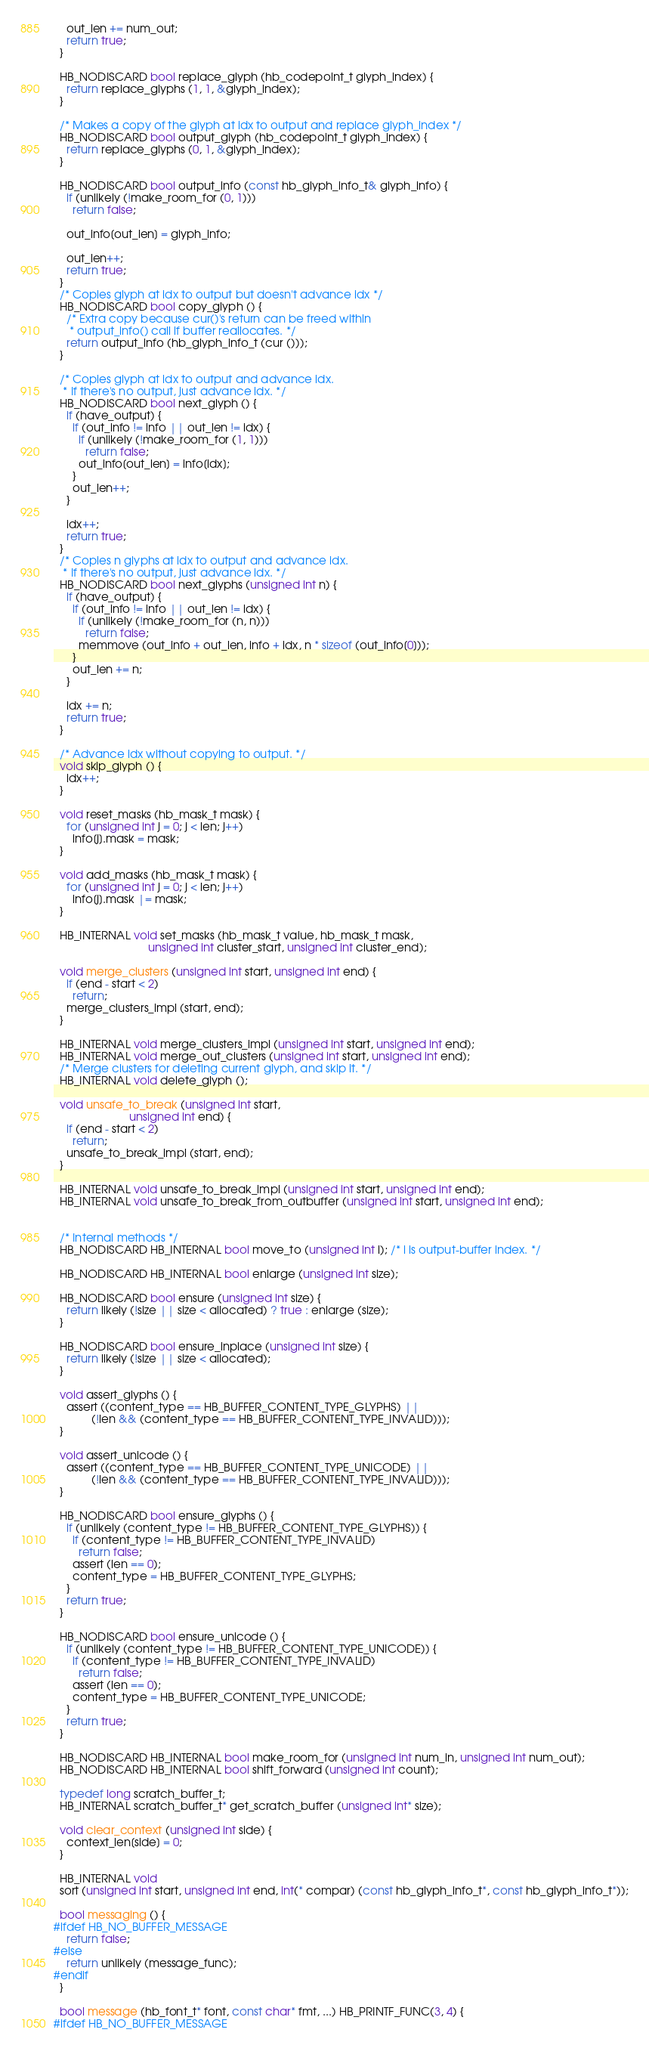<code> <loc_0><loc_0><loc_500><loc_500><_C++_>    out_len += num_out;
    return true;
  }

  HB_NODISCARD bool replace_glyph (hb_codepoint_t glyph_index) {
    return replace_glyphs (1, 1, &glyph_index);
  }

  /* Makes a copy of the glyph at idx to output and replace glyph_index */
  HB_NODISCARD bool output_glyph (hb_codepoint_t glyph_index) {
    return replace_glyphs (0, 1, &glyph_index);
  }

  HB_NODISCARD bool output_info (const hb_glyph_info_t& glyph_info) {
    if (unlikely (!make_room_for (0, 1)))
      return false;

    out_info[out_len] = glyph_info;

    out_len++;
    return true;
  }
  /* Copies glyph at idx to output but doesn't advance idx */
  HB_NODISCARD bool copy_glyph () {
    /* Extra copy because cur()'s return can be freed within
     * output_info() call if buffer reallocates. */
    return output_info (hb_glyph_info_t (cur ()));
  }

  /* Copies glyph at idx to output and advance idx.
   * If there's no output, just advance idx. */
  HB_NODISCARD bool next_glyph () {
    if (have_output) {
      if (out_info != info || out_len != idx) {
        if (unlikely (!make_room_for (1, 1)))
          return false;
        out_info[out_len] = info[idx];
      }
      out_len++;
    }

    idx++;
    return true;
  }
  /* Copies n glyphs at idx to output and advance idx.
   * If there's no output, just advance idx. */
  HB_NODISCARD bool next_glyphs (unsigned int n) {
    if (have_output) {
      if (out_info != info || out_len != idx) {
        if (unlikely (!make_room_for (n, n)))
          return false;
        memmove (out_info + out_len, info + idx, n * sizeof (out_info[0]));
      }
      out_len += n;
    }

    idx += n;
    return true;
  }

  /* Advance idx without copying to output. */
  void skip_glyph () {
    idx++;
  }

  void reset_masks (hb_mask_t mask) {
    for (unsigned int j = 0; j < len; j++)
      info[j].mask = mask;
  }

  void add_masks (hb_mask_t mask) {
    for (unsigned int j = 0; j < len; j++)
      info[j].mask |= mask;
  }

  HB_INTERNAL void set_masks (hb_mask_t value, hb_mask_t mask,
                              unsigned int cluster_start, unsigned int cluster_end);

  void merge_clusters (unsigned int start, unsigned int end) {
    if (end - start < 2)
      return;
    merge_clusters_impl (start, end);
  }

  HB_INTERNAL void merge_clusters_impl (unsigned int start, unsigned int end);
  HB_INTERNAL void merge_out_clusters (unsigned int start, unsigned int end);
  /* Merge clusters for deleting current glyph, and skip it. */
  HB_INTERNAL void delete_glyph ();

  void unsafe_to_break (unsigned int start,
                        unsigned int end) {
    if (end - start < 2)
      return;
    unsafe_to_break_impl (start, end);
  }

  HB_INTERNAL void unsafe_to_break_impl (unsigned int start, unsigned int end);
  HB_INTERNAL void unsafe_to_break_from_outbuffer (unsigned int start, unsigned int end);


  /* Internal methods */
  HB_NODISCARD HB_INTERNAL bool move_to (unsigned int i); /* i is output-buffer index. */

  HB_NODISCARD HB_INTERNAL bool enlarge (unsigned int size);

  HB_NODISCARD bool ensure (unsigned int size) {
    return likely (!size || size < allocated) ? true : enlarge (size);
  }

  HB_NODISCARD bool ensure_inplace (unsigned int size) {
    return likely (!size || size < allocated);
  }

  void assert_glyphs () {
    assert ((content_type == HB_BUFFER_CONTENT_TYPE_GLYPHS) ||
            (!len && (content_type == HB_BUFFER_CONTENT_TYPE_INVALID)));
  }

  void assert_unicode () {
    assert ((content_type == HB_BUFFER_CONTENT_TYPE_UNICODE) ||
            (!len && (content_type == HB_BUFFER_CONTENT_TYPE_INVALID)));
  }

  HB_NODISCARD bool ensure_glyphs () {
    if (unlikely (content_type != HB_BUFFER_CONTENT_TYPE_GLYPHS)) {
      if (content_type != HB_BUFFER_CONTENT_TYPE_INVALID)
        return false;
      assert (len == 0);
      content_type = HB_BUFFER_CONTENT_TYPE_GLYPHS;
    }
    return true;
  }

  HB_NODISCARD bool ensure_unicode () {
    if (unlikely (content_type != HB_BUFFER_CONTENT_TYPE_UNICODE)) {
      if (content_type != HB_BUFFER_CONTENT_TYPE_INVALID)
        return false;
      assert (len == 0);
      content_type = HB_BUFFER_CONTENT_TYPE_UNICODE;
    }
    return true;
  }

  HB_NODISCARD HB_INTERNAL bool make_room_for (unsigned int num_in, unsigned int num_out);
  HB_NODISCARD HB_INTERNAL bool shift_forward (unsigned int count);

  typedef long scratch_buffer_t;
  HB_INTERNAL scratch_buffer_t* get_scratch_buffer (unsigned int* size);

  void clear_context (unsigned int side) {
    context_len[side] = 0;
  }

  HB_INTERNAL void
  sort (unsigned int start, unsigned int end, int(* compar) (const hb_glyph_info_t*, const hb_glyph_info_t*));

  bool messaging () {
#ifdef HB_NO_BUFFER_MESSAGE
    return false;
#else
    return unlikely (message_func);
#endif
  }

  bool message (hb_font_t* font, const char* fmt, ...) HB_PRINTF_FUNC(3, 4) {
#ifdef HB_NO_BUFFER_MESSAGE</code> 